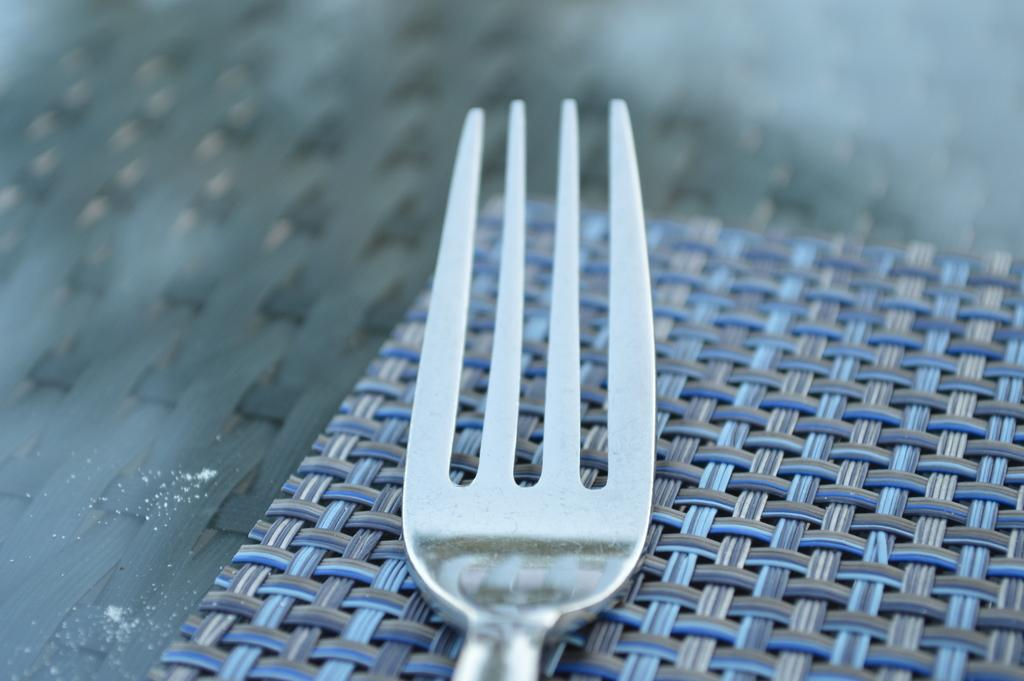What utensil is visible in the image? There is a fork in the image. Where is the fork placed? The fork is placed on a mat. What color is the mat? The mat is blue in color. What is the writer's name who is developing the story in the image? There is no writer or story development present in the image; it only features a fork placed on a blue mat. 